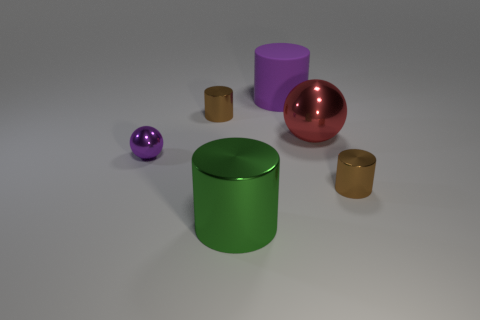Is there any other thing that has the same material as the purple cylinder?
Provide a succinct answer. No. What material is the brown cylinder that is to the left of the tiny brown shiny object that is in front of the purple sphere?
Offer a very short reply. Metal. Are there any large red metal balls in front of the big red object?
Your response must be concise. No. Are there more large red shiny things behind the big purple cylinder than purple cylinders?
Your response must be concise. No. Is there another metallic ball that has the same color as the large ball?
Keep it short and to the point. No. What is the color of the metal object that is the same size as the green cylinder?
Your answer should be compact. Red. Are there any big things in front of the small brown shiny object that is in front of the red sphere?
Your response must be concise. Yes. What is the tiny purple ball that is on the left side of the large red shiny thing made of?
Provide a short and direct response. Metal. Is the big cylinder to the left of the big purple object made of the same material as the brown cylinder that is left of the big red ball?
Give a very brief answer. Yes. Are there an equal number of large metal cylinders behind the large rubber thing and purple metallic balls in front of the green cylinder?
Offer a terse response. Yes. 